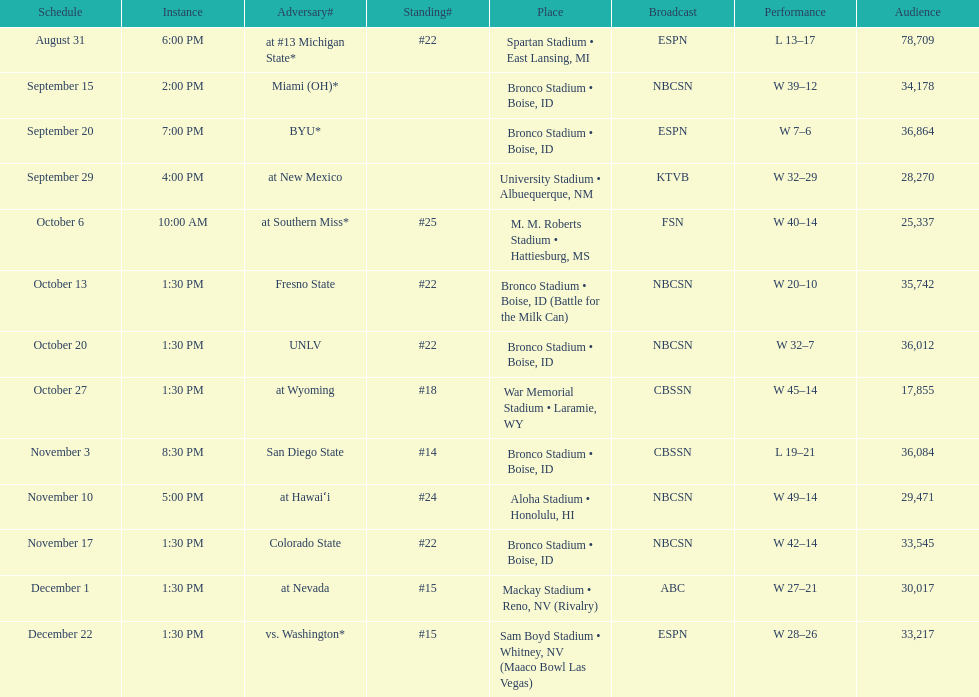Did the broncos on september 29th win by less than 5 points? Yes. 